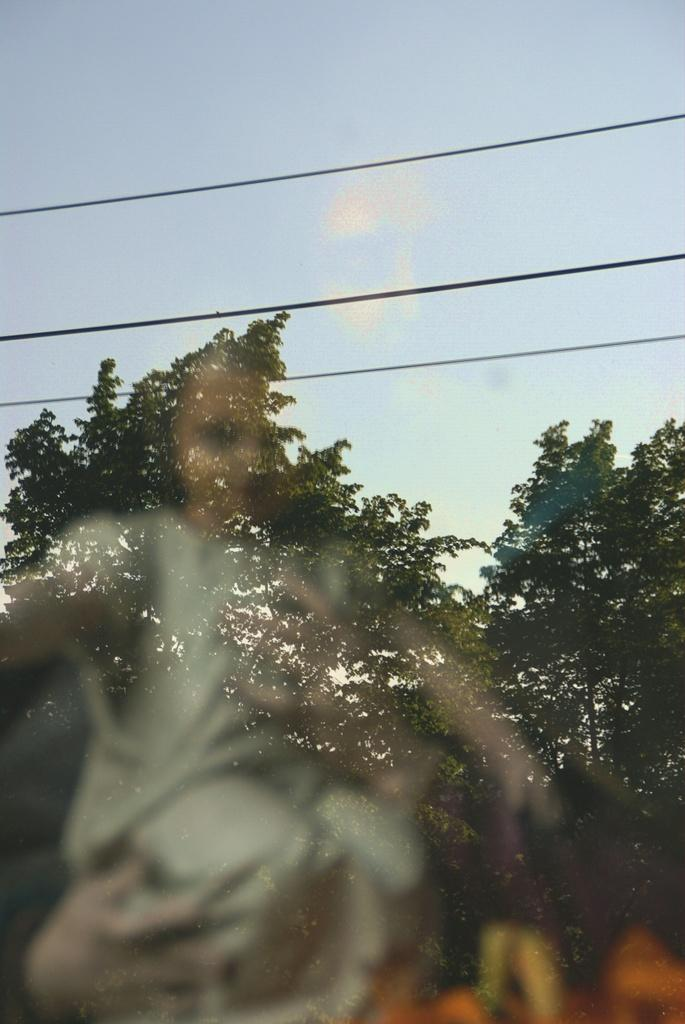What object is present in the image that can hold a liquid? There is a glass in the image. What can be seen in the reflection of the glass? The glass has a reflection of a person holding a baby. What type of natural scenery is visible outside the glass? There are trees visible outside the glass. What else can be seen outside the glass? There are wires and the sky with clouds visible outside the glass. How does the glass increase the size of the cake in the image? There is no cake present in the image, so the glass cannot increase its size. 